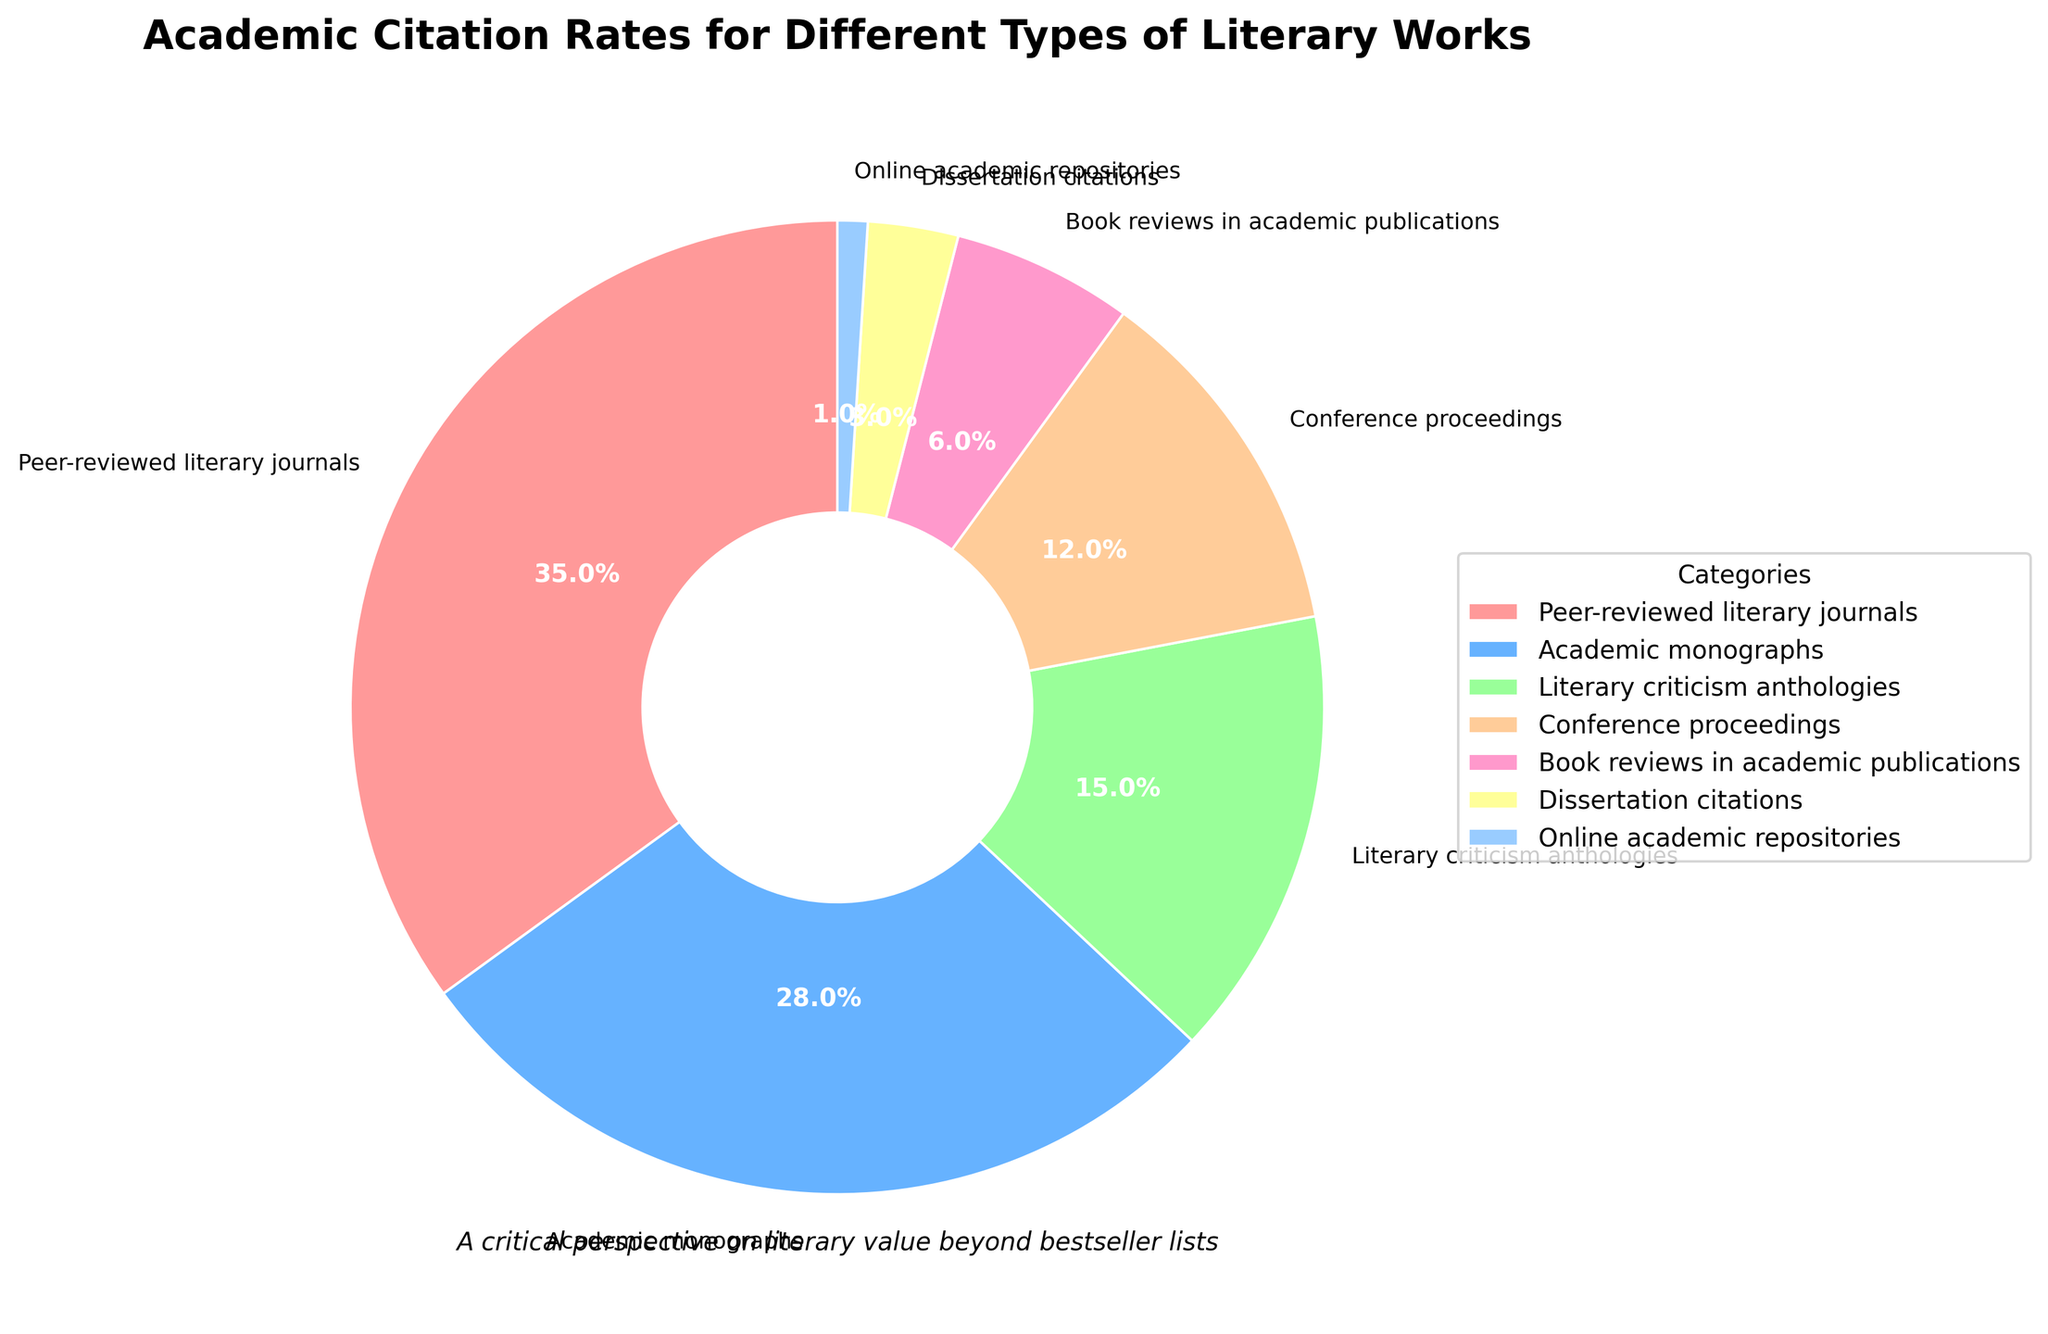What percentage of citations come from peer-reviewed literary journals? The figure includes percentages for various types of literary works. Locate the section labeled "Peer-reviewed literary journals" and note the percentage.
Answer: 35% Which category has the lowest citation rate? The pie chart shows the percentages of citations for different categories. Identify the category with the smallest percentage.
Answer: Online academic repositories How many more percentage points of citations do academic monographs have compared to dissertation citations? From the pie chart, note the percentages for academic monographs (28%) and dissertation citations (3%). Subtract the smaller percentage from the larger one to find the difference.
Answer: 25% What is the combined citation percentage of conference proceedings and book reviews in academic publications? Identify the percentages for both conference proceedings (12%) and book reviews in academic publications (6%) from the chart. Add these percentages together.
Answer: 18% Are citations from literary criticism anthologies more or less than half of those from peer-reviewed literary journals? First, determine half of the percentage of peer-reviewed literary journals by dividing 35% by 2, which is 17.5%. Then compare this with the percentage for literary criticism anthologies, which is 15%.
Answer: Less What percentage of citations are from sources other than peer-reviewed literary journals and academic monographs combined? Summing the percentages for peer-reviewed literary journals (35%) and academic monographs (28%) yields 63%. To find the remainder, subtract this from 100%.
Answer: 37% Which category appears visually largest on the pie chart? Identify which segment of the pie chart appears largest by inspecting the visual representation. This should coincide with the highest percentage value.
Answer: Peer-reviewed literary journals By how much do the citation percentages for literary criticism anthologies exceed those for book reviews in academic publications? Note the percentage for literary criticism anthologies (15%) and for book reviews in academic publications (6%) from the chart. Subtract the smaller percentage from the larger one.
Answer: 9% Which two categories combined have a citation percentage close to that of academic monographs? The percentage for academic monographs is 28%. Assess other categories to find two that together approximate this percentage. Conference proceedings (12%) and literary criticism anthologies (15%) combined yield 27%, which is closest.
Answer: Conference proceedings and literary criticism anthologies Does the pie chart suggest an even distribution of citation sources, or are certain categories more prominent? By visually examining the chart, observe if the pie slices (representing the different categories) are roughly equal or if some slices are noticeably larger. The pie chart shows larger slices for peer-reviewed literary journals and academic monographs, indicating a more prominent role for these categories in citations.
Answer: Certain categories are more prominent 